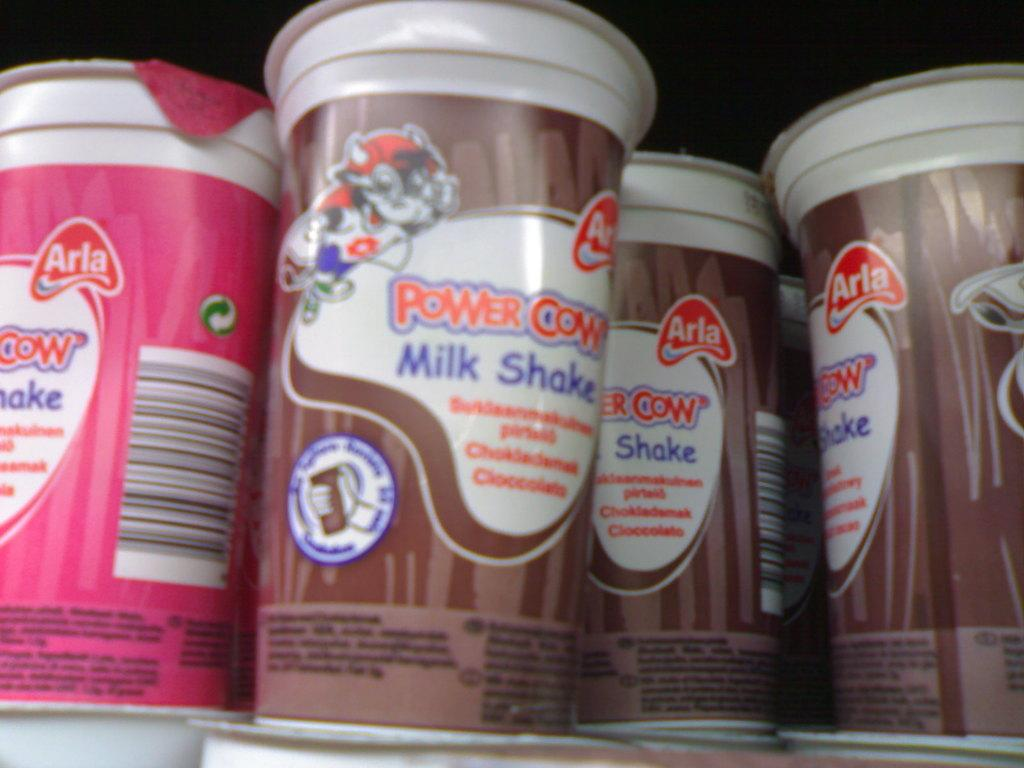What objects can be seen in the image? There are cups in the image. Can you describe the background of the image? The background of the image is dark. How many jellyfish are swimming in the scene depicted in the image? There are no jellyfish present in the image; it only features cups. What type of twist can be seen in the image? There is no twist visible in the image; it only contains cups and a dark background. 